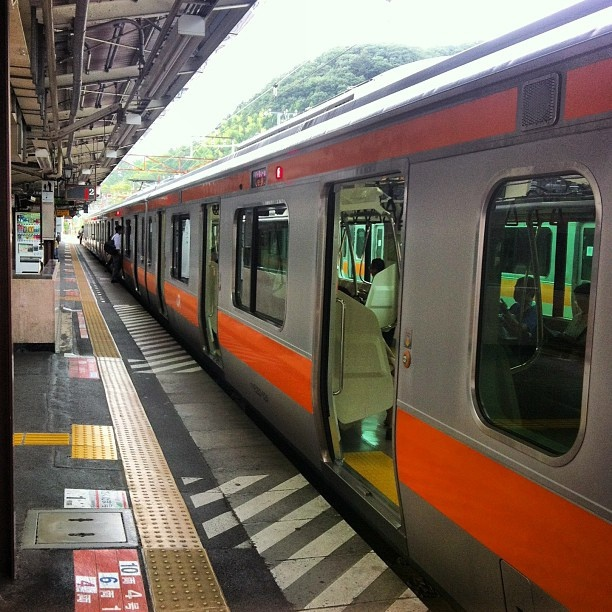Describe the objects in this image and their specific colors. I can see train in black, gray, brown, and darkgreen tones, people in black, darkgreen, teal, and green tones, people in black, darkgreen, and teal tones, people in black and gray tones, and people in black, darkgreen, gray, and darkgray tones in this image. 